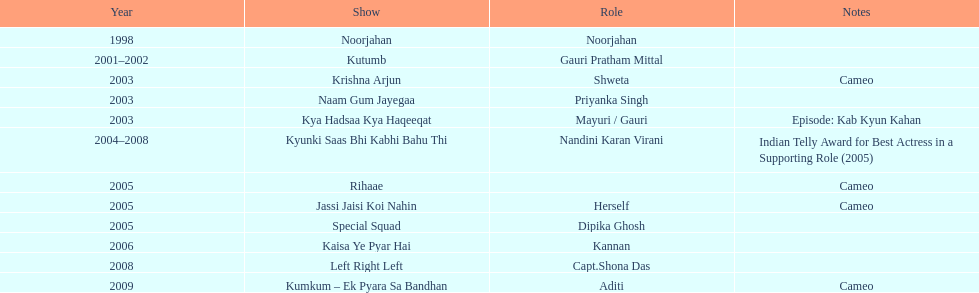What are all of the shows? Noorjahan, Kutumb, Krishna Arjun, Naam Gum Jayegaa, Kya Hadsaa Kya Haqeeqat, Kyunki Saas Bhi Kabhi Bahu Thi, Rihaae, Jassi Jaisi Koi Nahin, Special Squad, Kaisa Ye Pyar Hai, Left Right Left, Kumkum – Ek Pyara Sa Bandhan. When did they premiere? 1998, 2001–2002, 2003, 2003, 2003, 2004–2008, 2005, 2005, 2005, 2006, 2008, 2009. What notes are there for the shows from 2005? Cameo, Cameo. Along with rihaee, what is the other show gauri had a cameo role in? Jassi Jaisi Koi Nahin. 